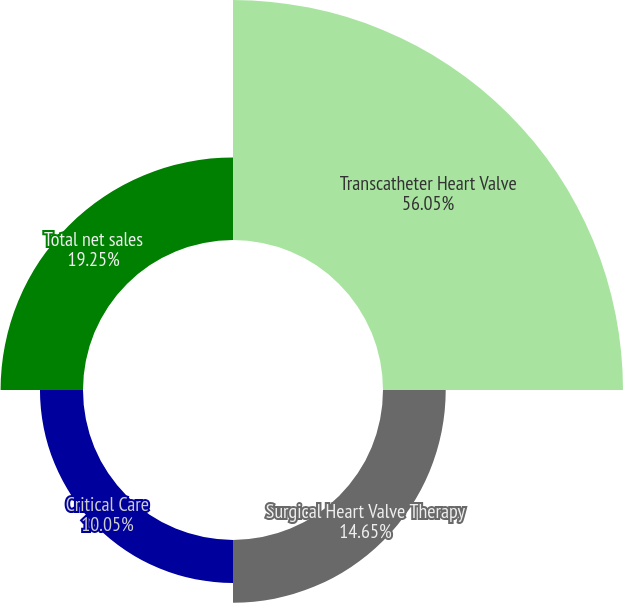Convert chart to OTSL. <chart><loc_0><loc_0><loc_500><loc_500><pie_chart><fcel>Transcatheter Heart Valve<fcel>Surgical Heart Valve Therapy<fcel>Critical Care<fcel>Total net sales<nl><fcel>56.05%<fcel>14.65%<fcel>10.05%<fcel>19.25%<nl></chart> 